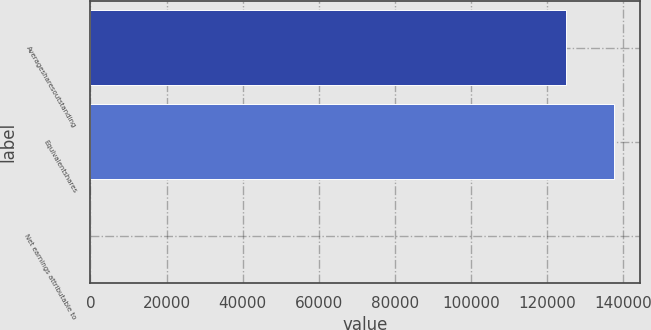Convert chart. <chart><loc_0><loc_0><loc_500><loc_500><bar_chart><fcel>Averagesharesoutstanding<fcel>Equivalentshares<fcel>Net earnings attributable to<nl><fcel>125039<fcel>137543<fcel>3.17<nl></chart> 